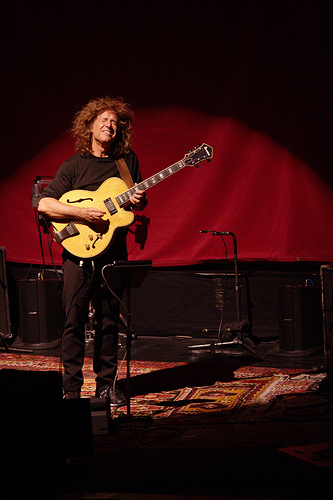<image>
Can you confirm if the guitar is behind the man? No. The guitar is not behind the man. From this viewpoint, the guitar appears to be positioned elsewhere in the scene. 